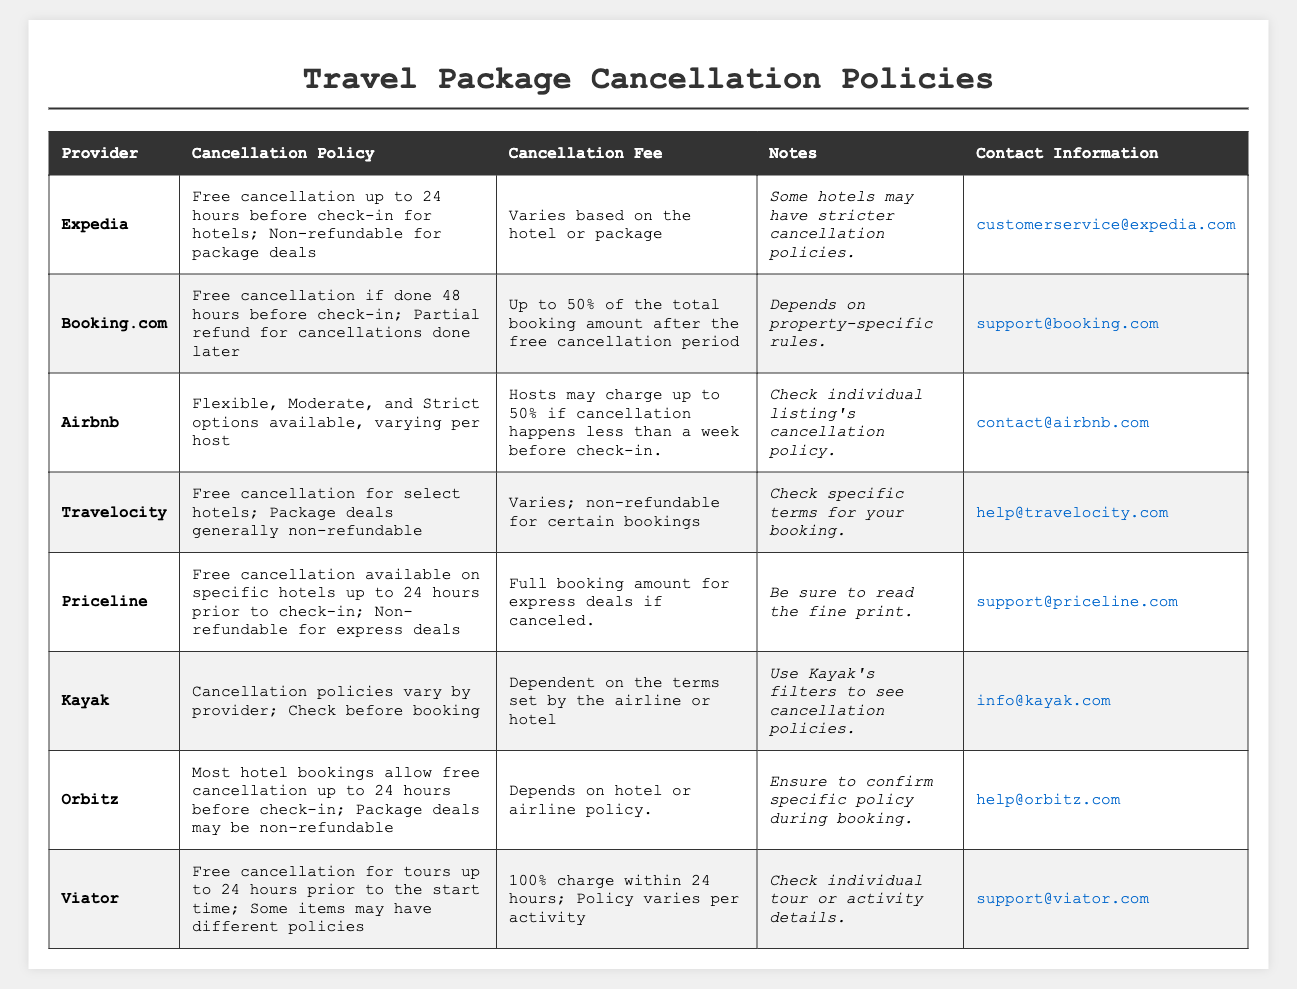What is the cancellation policy for Booking.com? According to the table, Booking.com offers free cancellation if done 48 hours before check-in, and a partial refund for cancellations made later.
Answer: Free cancellation if done 48 hours before check-in; partial refund later What fee does Priceline charge for express deals if canceled? The table specifies that Priceline charges the full booking amount for express deals if canceled.
Answer: Full booking amount Does Airbnb provide a flexible cancellation policy? Yes, Airbnb has flexible, moderate, and strict cancellation options available per host.
Answer: Yes What is the maximum cancellation fee on Airbnb for last-minute cancellations? The table states that hosts may charge up to 50% if cancellation happens less than a week before check-in.
Answer: Up to 50% Is Expedia's cancellation policy the same for hotels and package deals? No, the cancellation policy differs; hotels offer free cancellation up to 24 hours before check-in, while package deals are non-refundable.
Answer: No Which providers offer free cancellation for hotel bookings? The table lists Expedia, Booking.com, Priceline, Orbitz, and Travelocity as providers that offer free cancellation for hotels under certain conditions.
Answer: Expedia, Booking.com, Priceline, Orbitz, Travelocity If a customer books on Viator, when is the latest they can cancel for a full refund? The table indicates that Viator allows free cancellation for tours up to 24 hours prior to the start time; thus, cancellations within 24 hours would incur a 100% charge.
Answer: 24 hours prior How does the cancellation fee vary among different providers? The cancellation fees vary as follows: Expedia varies by booking, Booking.com can be up to 50%, Airbnb may charge up to 50%, and others have their specific terms like non-refundable deals.
Answer: Varies by provider If a customer cancels a Travelocity package deal, what is the likely outcome? The table notes that package deals with Travelocity are generally non-refundable, so likely no refund will be issued.
Answer: Non-refundable Which provider's cancellation policy is reliant on the property's specific rules? Booking.com states the cancellation fee depends on property-specific rules, and Airbnb emphasizes checking individual listing’s cancellation policy.
Answer: Booking.com and Airbnb 